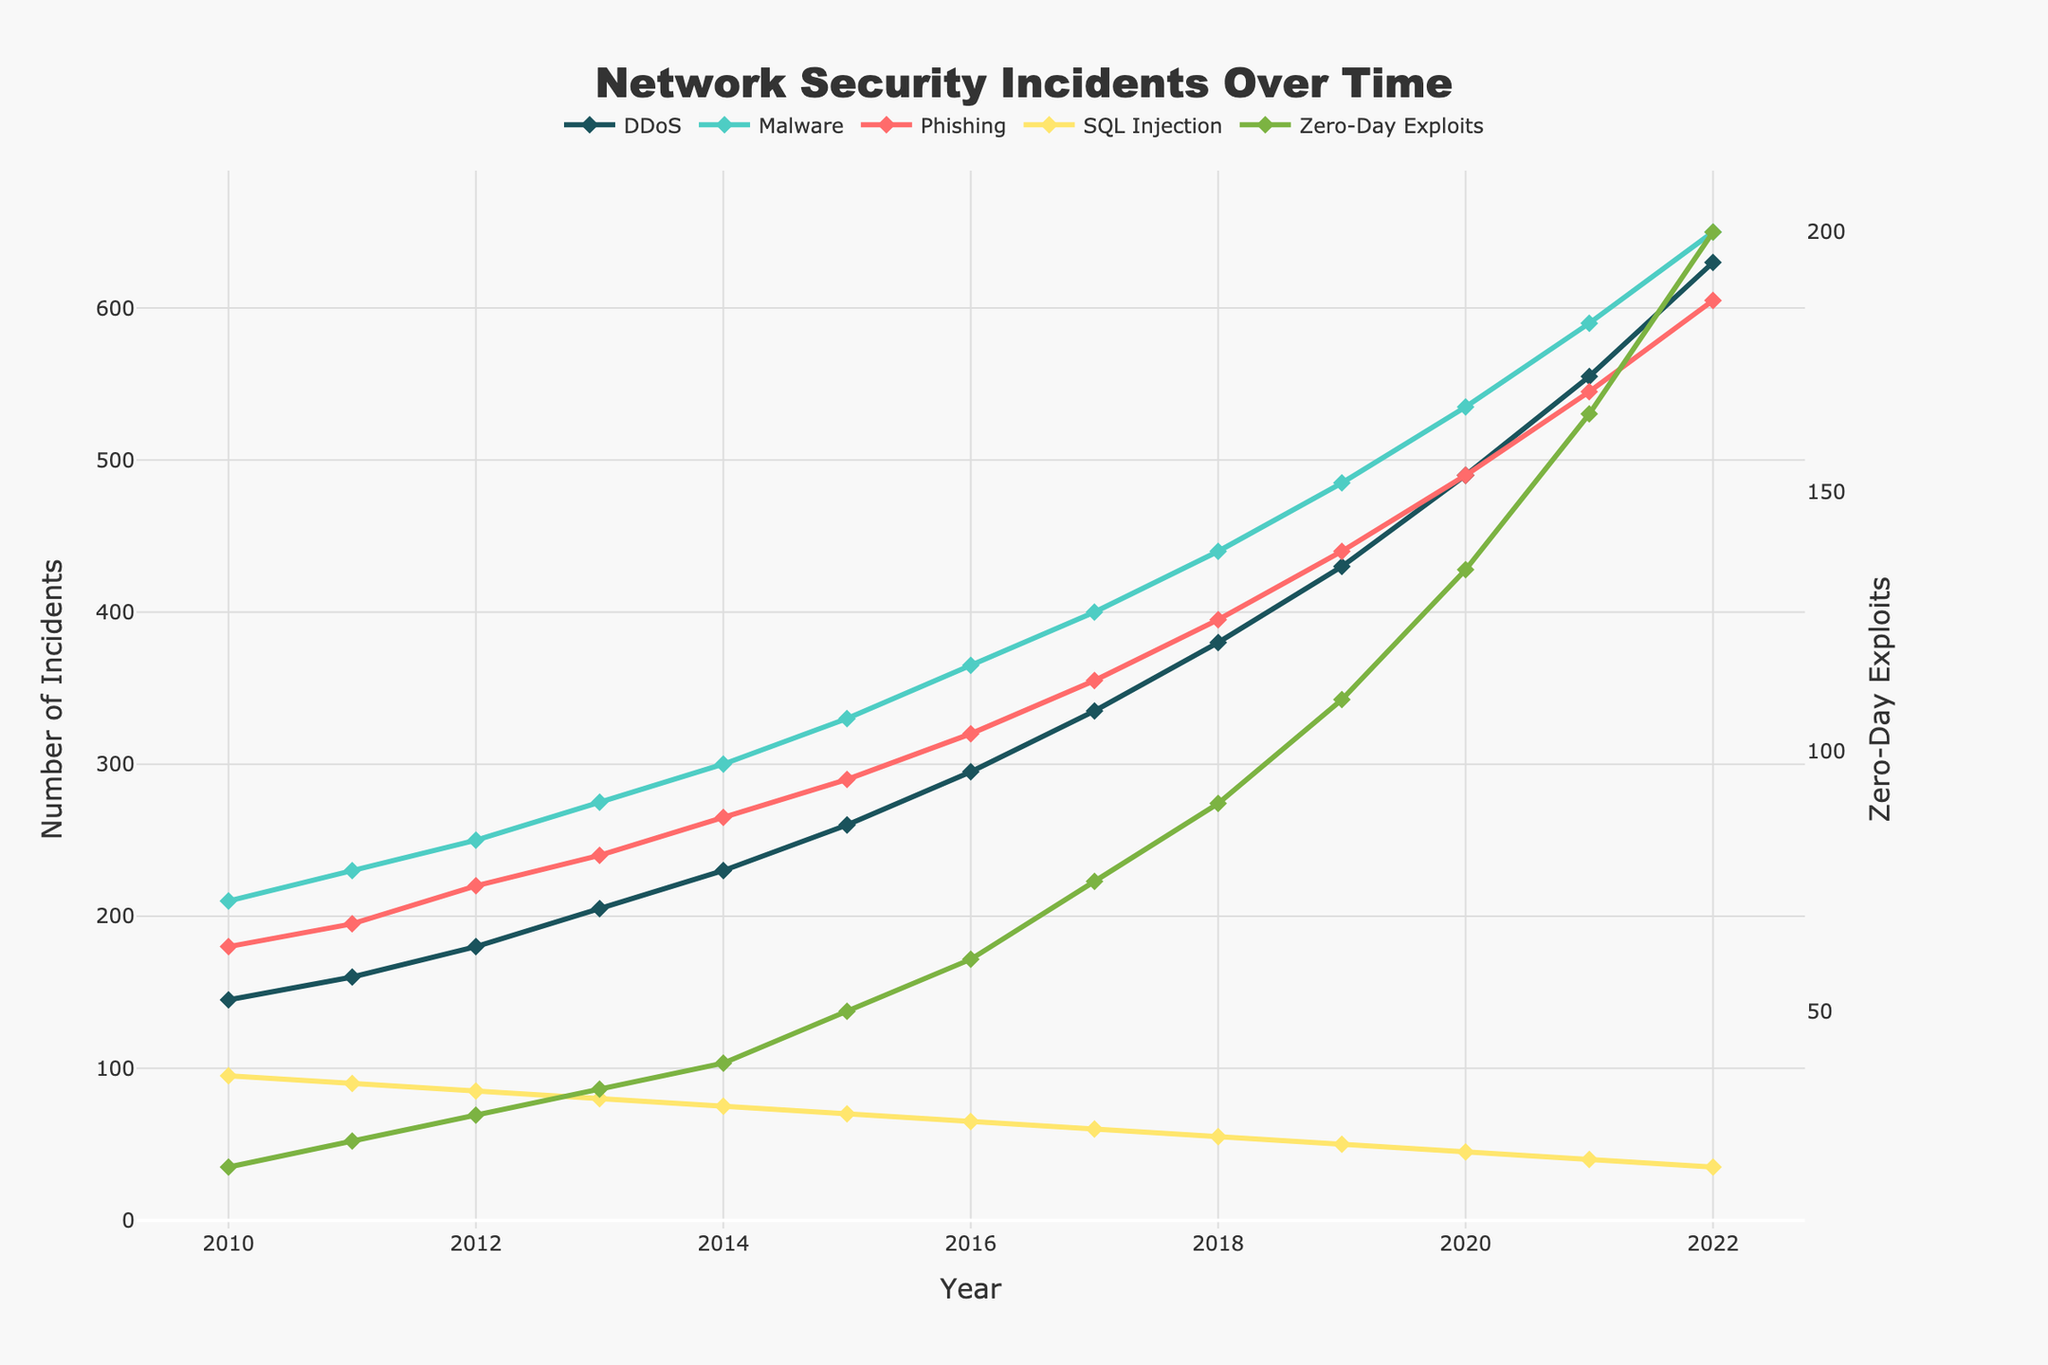what is the total number of each type of incident in 2015? To find the total number of each type of incident in 2015, simply locate the 2015 values on the lines representing each attack type. For instance, DDoS is 260, Malware is 330, Phishing is 290, SQL Injection is 70, and Zero-Day Exploits is 50.
Answer: DDoS: 260, Malware: 330, Phishing: 290, SQL Injection: 70, Zero-Day Exploits: 50 Which type of attack saw the largest increase from 2010 to 2022? Identify the difference in the number of incidents from 2010 to 2022 for each type of attack. For instance, DDoS increased by (630-145)=485, Malware by (650-210)=440, Phishing by (605-180)=425, SQL Injection by (35-95)=-60, and Zero-Day Exploits by (200-20)=180. DDoS has the largest increase.
Answer: DDoS In which year did Phishing incidents exceed Malware incidents by the smallest margin? By comparing Phishing and Malware lines for each year, one can observe the smallest margin where Phishing exceeds Malware, specifically in 2014 where Phishing (265) exceeds Malware (300) by (300-265)=35.
Answer: 2014 What year experienced a noticeable spike in Malware incidents based on the visual trend? The Malware line shows a significant jump around 2017-2018 where incidents went from 400 (2017) to 440 (2018), indicating a noticeable spike.
Answer: 2017-2018 Comparing DDoS and Phishing trends, which year had their incident numbers closest? By noting the close values on the DDoS and Phishing lines, in 2012, DDoS (180) and Phishing (220) are closest compared to other years.
Answer: 2012 Which attack type consistently increased every year from 2010 to 2022? Reviewing each line for consistent year-over-year increments from 2010 to 2022, both DDoS, Malware, and Phishing exhibit consistent increases. However, Zero-Day Exploits also consistently increased, so it qualifies.
Answer: Zero-Day Exploits What's the difference in 2021 between the number of SQL Injection incidents and Zero-Day Exploits? For 2021, deduct SQL Injection incidents (40) from Zero-Day Exploits (165) resulting in 165 - 40 = 125.
Answer: 125 Which attack type had the least incidents in 2010? The visual data shows the lowest line or point in 2010 belongs to Zero-Day Exploits, which has 20 incidents.
Answer: Zero-Day Exploits Analyzing the colors, which type of attack is represented by the green line? The green line in the plot represents the SQL Injection attack type.
Answer: SQL Injection By how much did DDoS incidents increase between 2019 and 2020? Subtract the DDoS incidents in 2019 (430) from those in 2020 (490), resulting in an increase of 490 - 430 = 60.
Answer: 60 